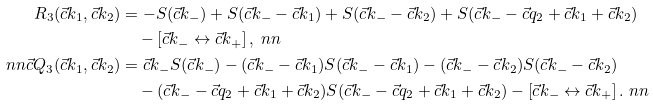Convert formula to latex. <formula><loc_0><loc_0><loc_500><loc_500>R _ { 3 } ( \vec { c } { k _ { 1 } } , \vec { c } { k _ { 2 } } ) & = - S ( \vec { c } { k _ { - } } ) + S ( \vec { c } { k _ { - } } - \vec { c } { k _ { 1 } } ) + S ( \vec { c } { k _ { - } } - \vec { c } { k _ { 2 } } ) + S ( \vec { c } { k _ { - } } - \vec { c } { q _ { 2 } } + \vec { c } { k _ { 1 } } + \vec { c } { k _ { 2 } } ) \\ & \quad - \left [ \vec { c } { k _ { - } } \leftrightarrow \vec { c } { k _ { + } } \right ] , \ n n \\ \ n n \vec { c } { Q _ { 3 } } ( \vec { c } { k _ { 1 } } , \vec { c } { k _ { 2 } } ) & = \vec { c } { k _ { - } } S ( \vec { c } { k _ { - } } ) - ( \vec { c } { k _ { - } } - \vec { c } { k _ { 1 } } ) S ( \vec { c } { k _ { - } } - \vec { c } { k _ { 1 } } ) - ( \vec { c } { k _ { - } } - \vec { c } { k _ { 2 } } ) S ( \vec { c } { k _ { - } } - \vec { c } { k _ { 2 } } ) \\ & \quad - ( \vec { c } { k _ { - } } - \vec { c } { q _ { 2 } } + \vec { c } { k _ { 1 } } + \vec { c } { k _ { 2 } } ) S ( \vec { c } { k _ { - } } - \vec { c } { q _ { 2 } } + \vec { c } { k _ { 1 } } + \vec { c } { k _ { 2 } } ) - \left [ \vec { c } { k _ { - } } \leftrightarrow \vec { c } { k _ { + } } \right ] . \ n n</formula> 